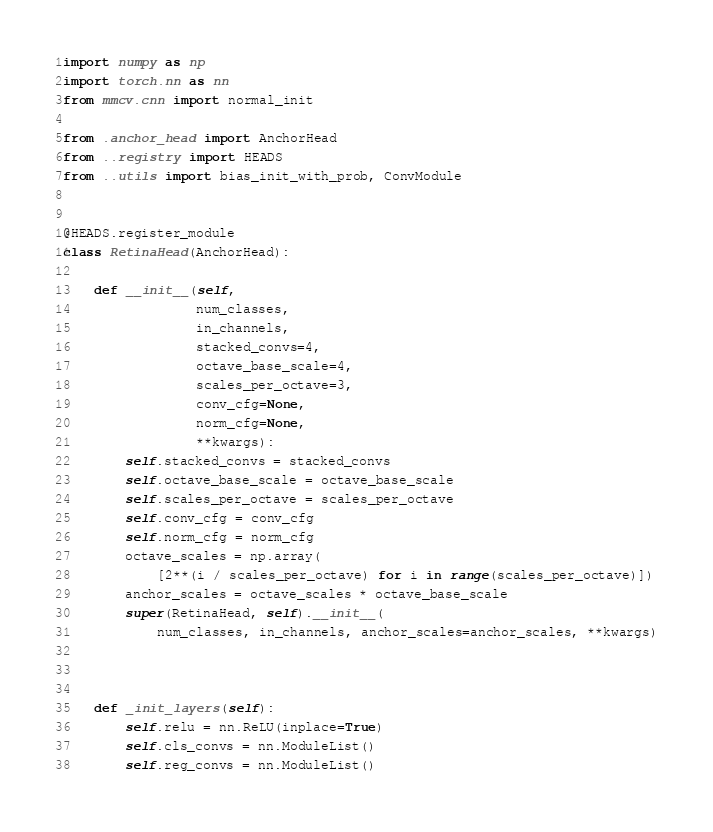Convert code to text. <code><loc_0><loc_0><loc_500><loc_500><_Python_>import numpy as np
import torch.nn as nn
from mmcv.cnn import normal_init

from .anchor_head import AnchorHead
from ..registry import HEADS
from ..utils import bias_init_with_prob, ConvModule


@HEADS.register_module
class RetinaHead(AnchorHead):

    def __init__(self,
                 num_classes,
                 in_channels,
                 stacked_convs=4,
                 octave_base_scale=4,
                 scales_per_octave=3,
                 conv_cfg=None,
                 norm_cfg=None,
                 **kwargs):
        self.stacked_convs = stacked_convs
        self.octave_base_scale = octave_base_scale
        self.scales_per_octave = scales_per_octave
        self.conv_cfg = conv_cfg
        self.norm_cfg = norm_cfg
        octave_scales = np.array(
            [2**(i / scales_per_octave) for i in range(scales_per_octave)])
        anchor_scales = octave_scales * octave_base_scale
        super(RetinaHead, self).__init__(
            num_classes, in_channels, anchor_scales=anchor_scales, **kwargs)



    def _init_layers(self):
        self.relu = nn.ReLU(inplace=True)
        self.cls_convs = nn.ModuleList()
        self.reg_convs = nn.ModuleList()</code> 